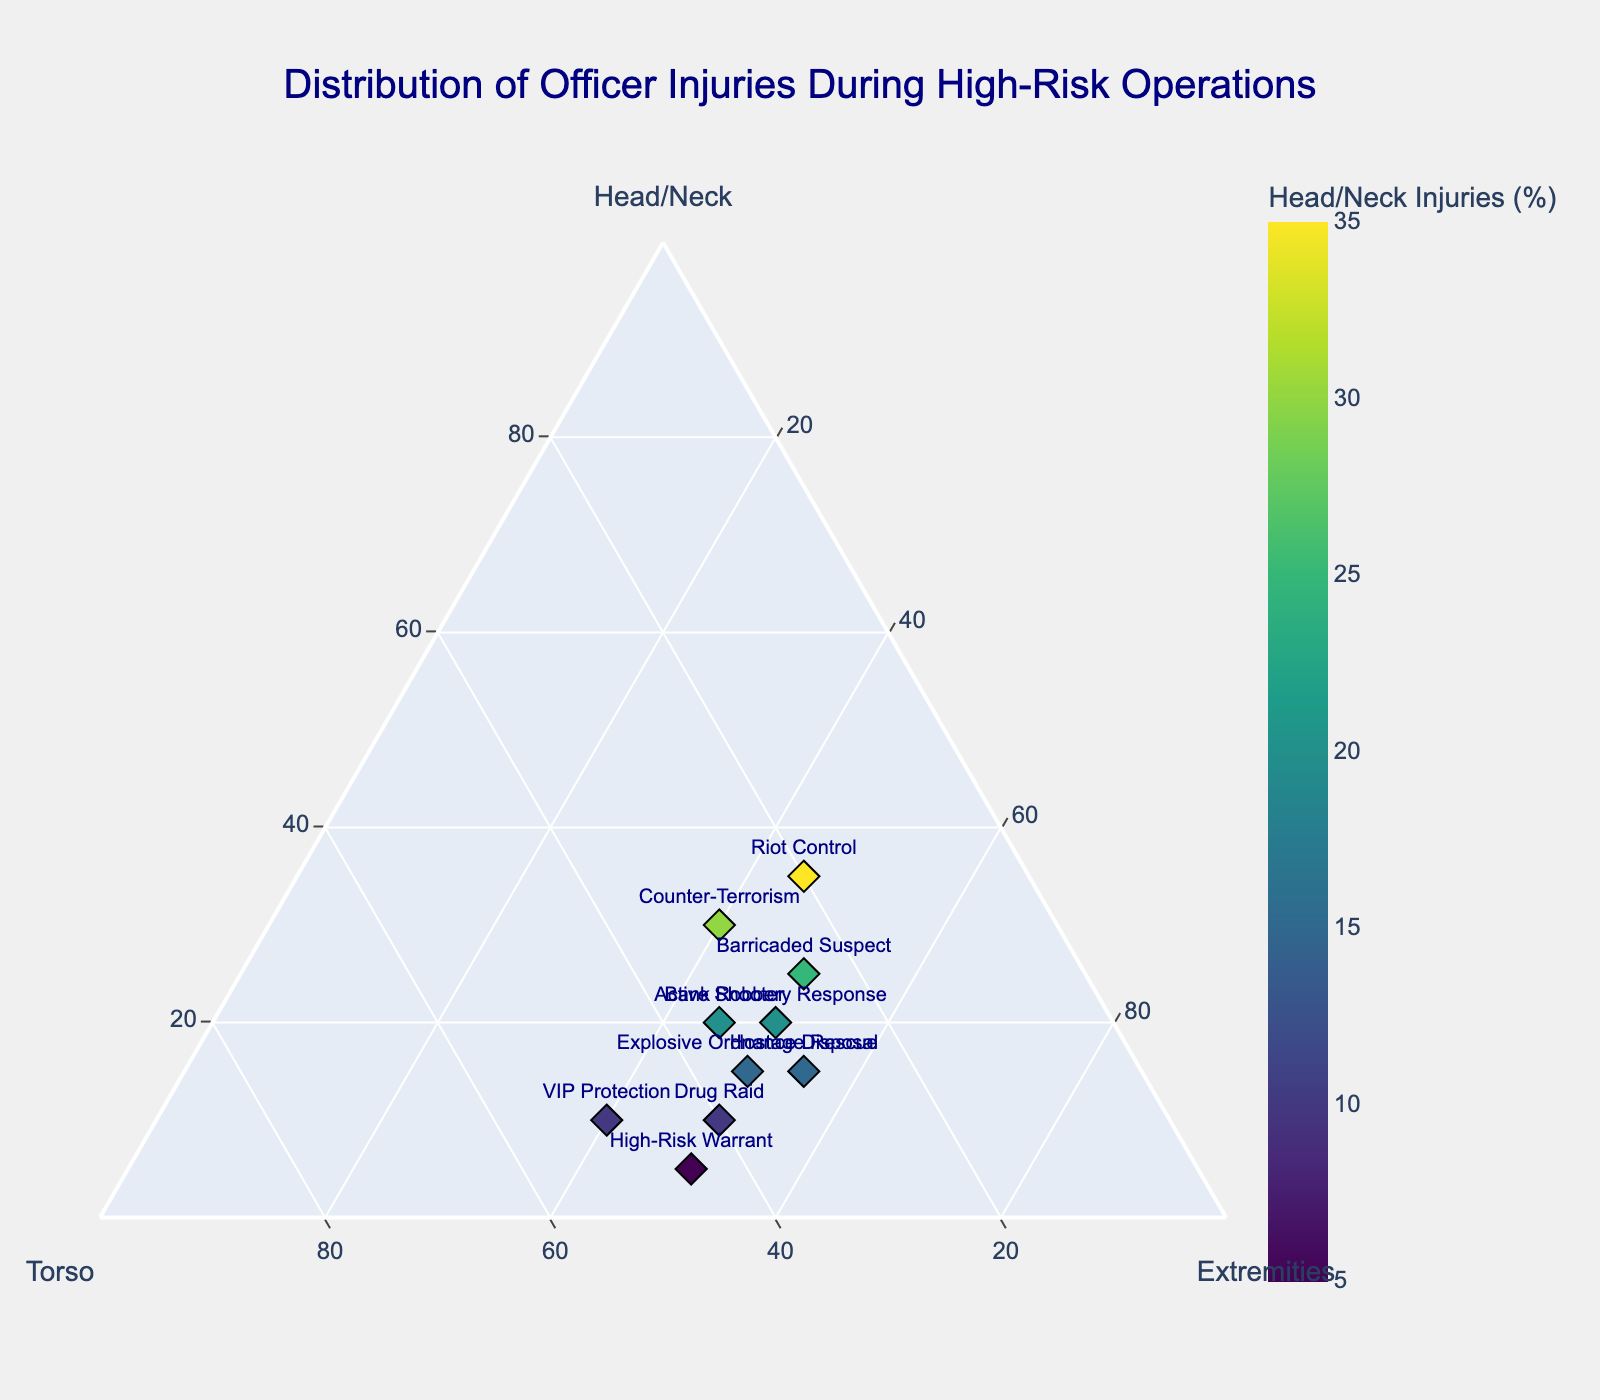what is the title of the plot? The title is displayed at the top center of the plot and reads "Distribution of Officer Injuries During High-Risk Operations".
Answer: Distribution of Officer Injuries During High-Risk Operations how many operations are represented in the plot? Each operation is marked by a diamond symbol and a text label. By counting these labels, we can see there are 10 operations.
Answer: 10 which operation has the highest percentage of injuries to the head/neck? We need to look for the data point with the highest value on the 'Head/Neck' axis. The operation with the highest percentage is "Riot Control" with 35%.
Answer: Riot Control which operations have equal percentages of injuries to the torso? By comparing the values on the 'Torso' axis, we see that "Hostage Rescue", "Counter-Terrorism", "Bank Robbery Response", and "Explosive Ordnance Disposal" all have 30%.
Answer: Hostage Rescue, Counter-Terrorism, Bank Robbery Response, Explosive Ordnance Disposal What is the combined total of torso injuries across “Drug Raid” and “VIP Protection”? Add the torso injury percentages for "Drug Raid" (40%) and "VIP Protection" (50%), which gives 40 + 50 = 90.
Answer: 90 which operation has the smallest percentage of head/neck injuries? By identifying the smallest value on the 'Head/Neck' axis, "High-Risk Warrant" has only 5%.
Answer: High-Risk Warrant what proportion of the total injuries for "Active Shooter" occurred in the extremities? For "Active Shooter", the percentage of injuries in the extremities is 45%. Given the total is always 100%, the proportion is 45/100 or 45%.
Answer: 45% How does the percentage of torso injuries in “Barricaded Suspect” compare to that in “Hostage Rescue”? "Barricaded Suspect" has 25% torso injuries, and "Hostage Rescue" has 30%. Therefore, "Barricaded Suspect" has 5% less than "Hostage Rescue".
Answer: Barricaded Suspect has 5% less than Hostage Rescue which operations show equal distribution between head/neck, torso, and extremities? An equal distribution implies each category has around 33.3%. No operations meet this exact criterion, so the answer is none.
Answer: none 